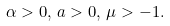<formula> <loc_0><loc_0><loc_500><loc_500>\alpha > 0 , \, a > 0 , \, \mu > - 1 .</formula> 